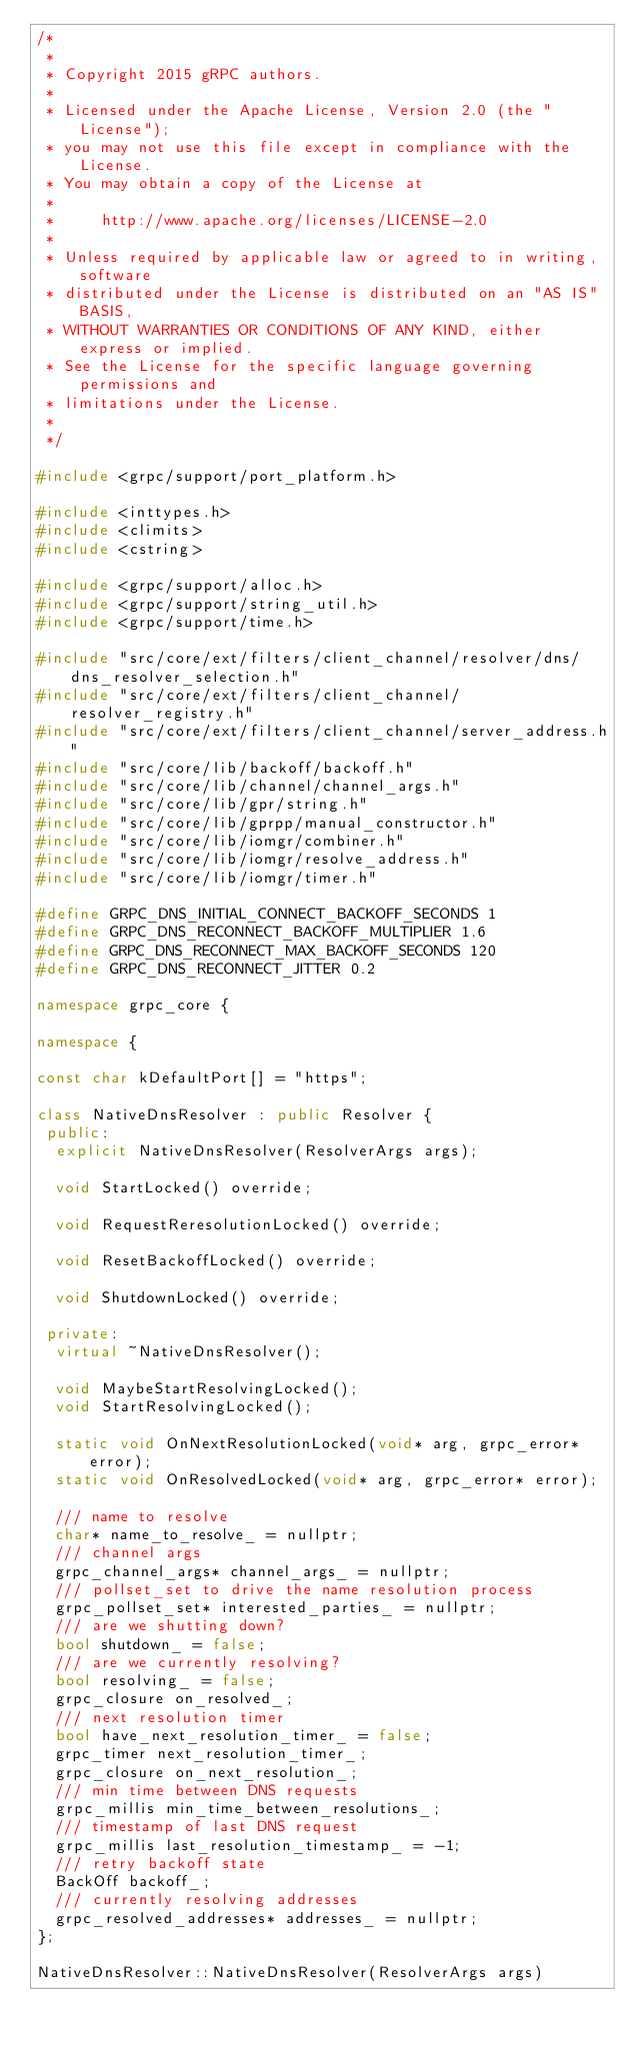<code> <loc_0><loc_0><loc_500><loc_500><_C++_>/*
 *
 * Copyright 2015 gRPC authors.
 *
 * Licensed under the Apache License, Version 2.0 (the "License");
 * you may not use this file except in compliance with the License.
 * You may obtain a copy of the License at
 *
 *     http://www.apache.org/licenses/LICENSE-2.0
 *
 * Unless required by applicable law or agreed to in writing, software
 * distributed under the License is distributed on an "AS IS" BASIS,
 * WITHOUT WARRANTIES OR CONDITIONS OF ANY KIND, either express or implied.
 * See the License for the specific language governing permissions and
 * limitations under the License.
 *
 */

#include <grpc/support/port_platform.h>

#include <inttypes.h>
#include <climits>
#include <cstring>

#include <grpc/support/alloc.h>
#include <grpc/support/string_util.h>
#include <grpc/support/time.h>

#include "src/core/ext/filters/client_channel/resolver/dns/dns_resolver_selection.h"
#include "src/core/ext/filters/client_channel/resolver_registry.h"
#include "src/core/ext/filters/client_channel/server_address.h"
#include "src/core/lib/backoff/backoff.h"
#include "src/core/lib/channel/channel_args.h"
#include "src/core/lib/gpr/string.h"
#include "src/core/lib/gprpp/manual_constructor.h"
#include "src/core/lib/iomgr/combiner.h"
#include "src/core/lib/iomgr/resolve_address.h"
#include "src/core/lib/iomgr/timer.h"

#define GRPC_DNS_INITIAL_CONNECT_BACKOFF_SECONDS 1
#define GRPC_DNS_RECONNECT_BACKOFF_MULTIPLIER 1.6
#define GRPC_DNS_RECONNECT_MAX_BACKOFF_SECONDS 120
#define GRPC_DNS_RECONNECT_JITTER 0.2

namespace grpc_core {

namespace {

const char kDefaultPort[] = "https";

class NativeDnsResolver : public Resolver {
 public:
  explicit NativeDnsResolver(ResolverArgs args);

  void StartLocked() override;

  void RequestReresolutionLocked() override;

  void ResetBackoffLocked() override;

  void ShutdownLocked() override;

 private:
  virtual ~NativeDnsResolver();

  void MaybeStartResolvingLocked();
  void StartResolvingLocked();

  static void OnNextResolutionLocked(void* arg, grpc_error* error);
  static void OnResolvedLocked(void* arg, grpc_error* error);

  /// name to resolve
  char* name_to_resolve_ = nullptr;
  /// channel args
  grpc_channel_args* channel_args_ = nullptr;
  /// pollset_set to drive the name resolution process
  grpc_pollset_set* interested_parties_ = nullptr;
  /// are we shutting down?
  bool shutdown_ = false;
  /// are we currently resolving?
  bool resolving_ = false;
  grpc_closure on_resolved_;
  /// next resolution timer
  bool have_next_resolution_timer_ = false;
  grpc_timer next_resolution_timer_;
  grpc_closure on_next_resolution_;
  /// min time between DNS requests
  grpc_millis min_time_between_resolutions_;
  /// timestamp of last DNS request
  grpc_millis last_resolution_timestamp_ = -1;
  /// retry backoff state
  BackOff backoff_;
  /// currently resolving addresses
  grpc_resolved_addresses* addresses_ = nullptr;
};

NativeDnsResolver::NativeDnsResolver(ResolverArgs args)</code> 